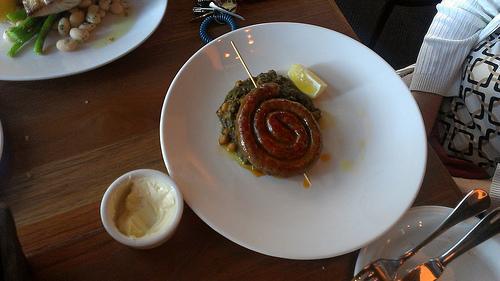How many cups are on the table?
Give a very brief answer. 1. 